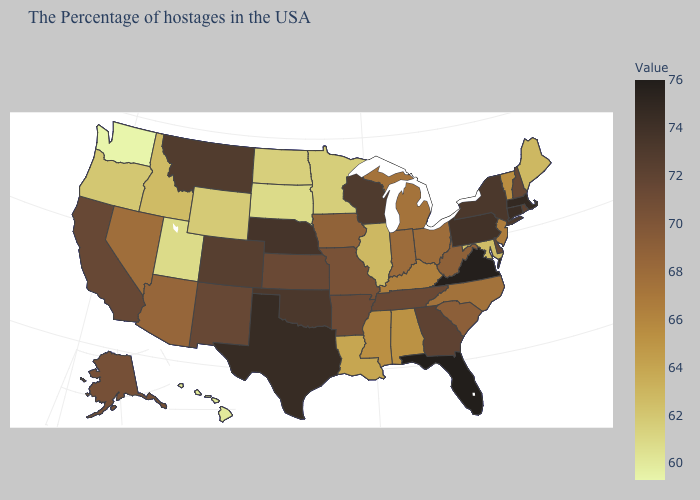Does Washington have the lowest value in the USA?
Write a very short answer. Yes. Is the legend a continuous bar?
Concise answer only. Yes. Is the legend a continuous bar?
Short answer required. Yes. Which states have the lowest value in the South?
Be succinct. Maryland. Among the states that border Arizona , which have the lowest value?
Give a very brief answer. Utah. 